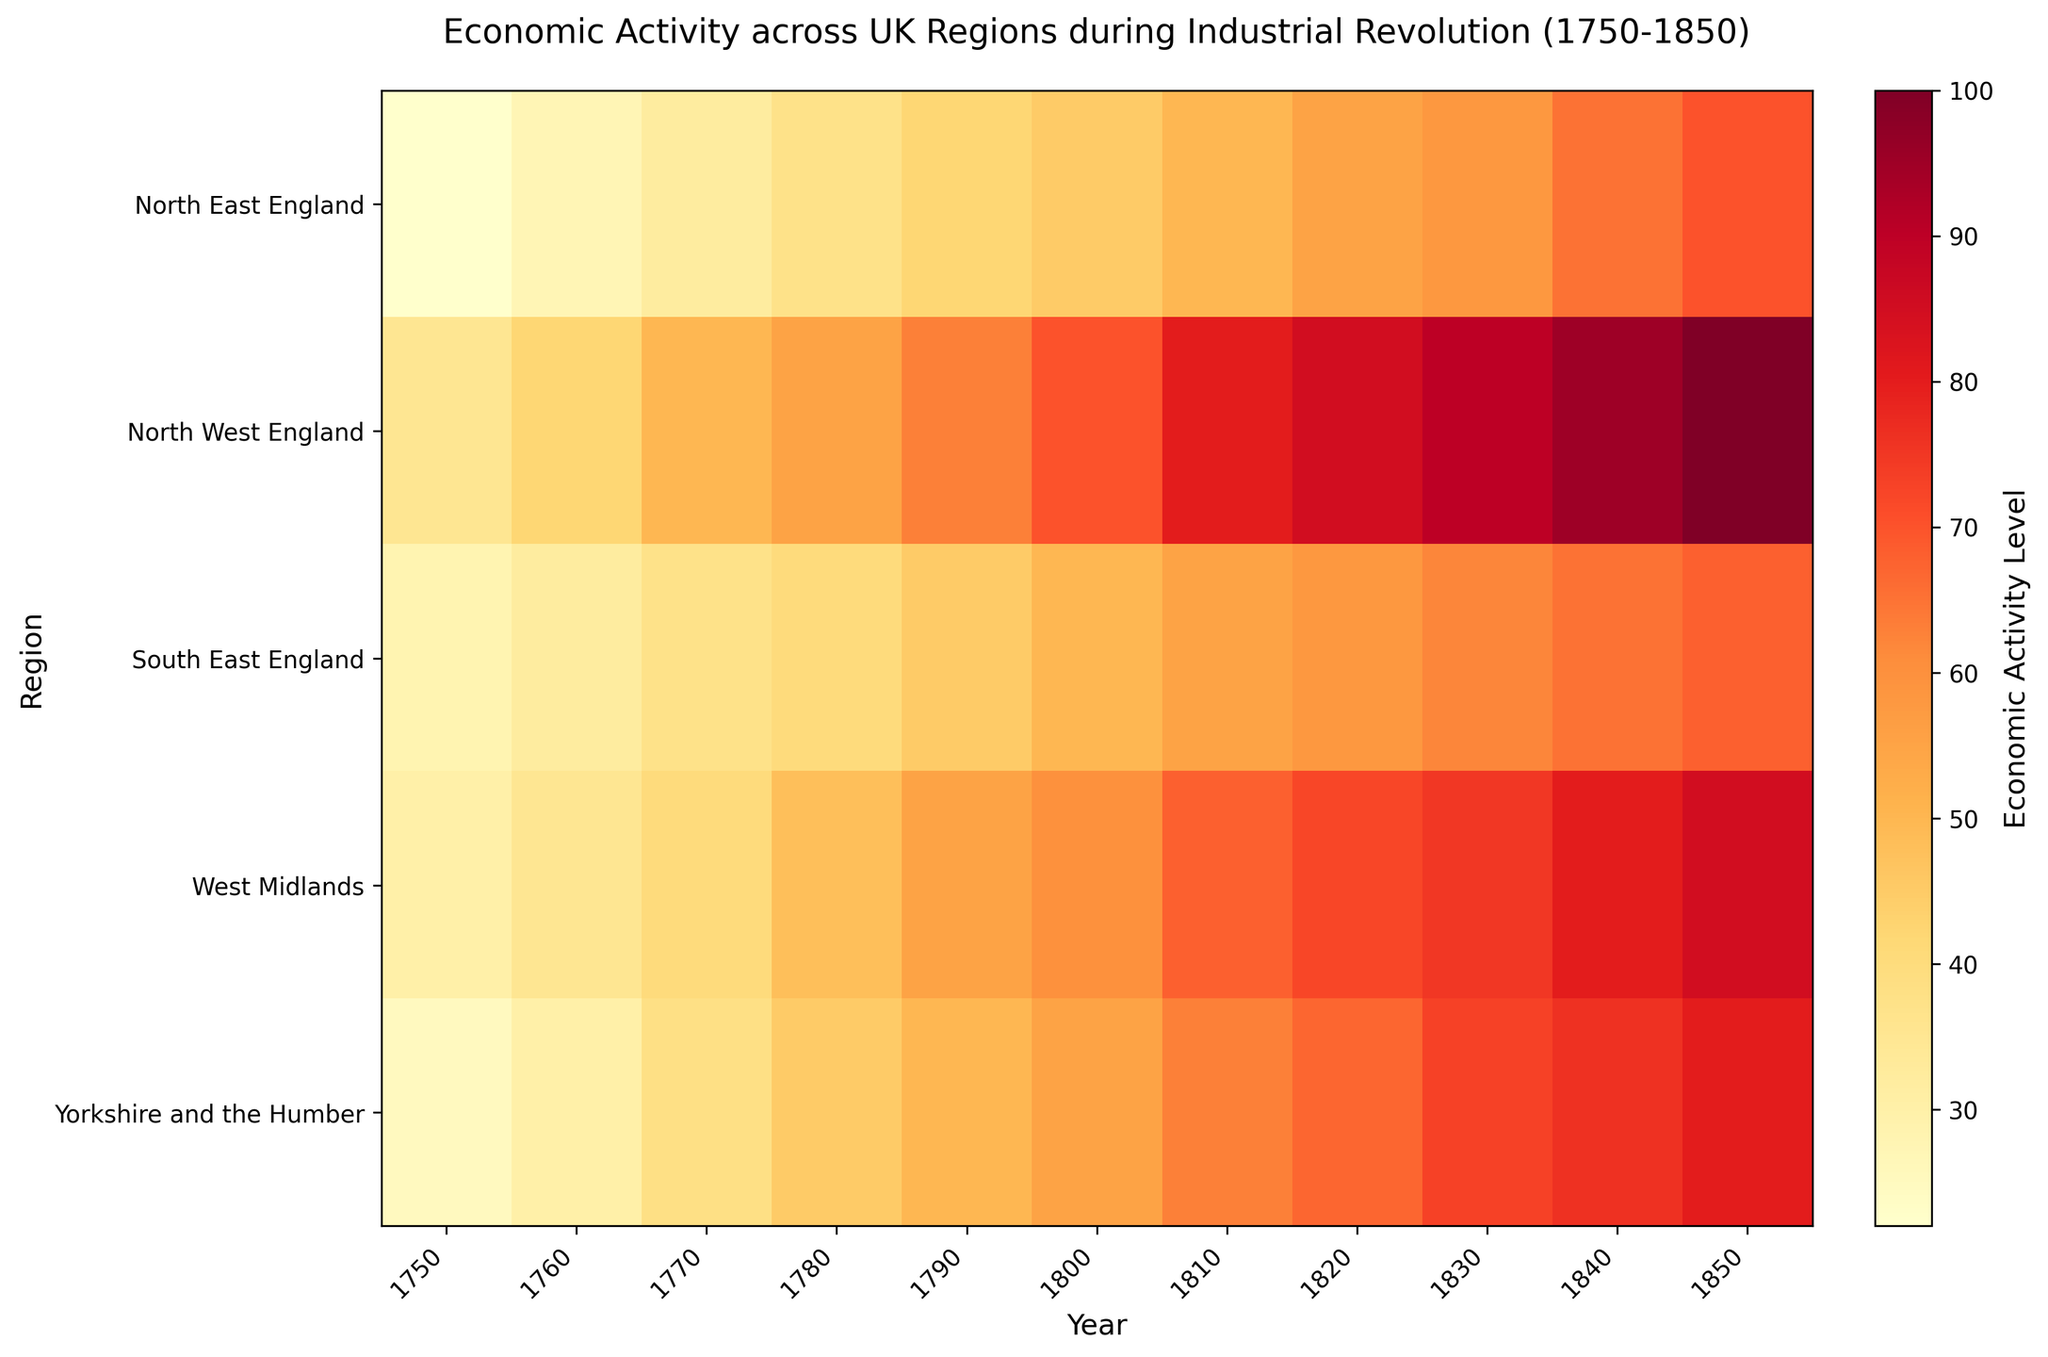What regions show the highest economic activity in the year 1850? To find the regions with the highest economic activity in 1850, look at the heatmap's rightmost column and identify the regions with the darkest (most intense) red color. The highest values indicate North West England.
Answer: North West England Which region had a higher increase in economic activity from 1750 to 1850, North West England or South East England? Calculate the increase for both regions by subtracting the 1750 value from the 1850 value. For North West England, the increase is 100 - 35 = 65. For South East England, it’s 68 - 28 = 40. Compare the two increases to find the greater one.
Answer: North West England How does the economic activity in Yorkshire and the Humber in 1830 compare to that in North East England in 1850? Look at the value for Yorkshire and the Humber in 1830 and compare it to North East England in 1850. Yorkshire and the Humber in 1830 is 73, and North East England in 1850 is 70. Since 73 is greater than 70, Yorkshire and the Humber in 1830 had higher economic activity.
Answer: Yorkshire and the Humber had higher economic activity What is the difference in economic activity between West Midlands and North East England in 1840? Find the values for West Midlands and North East England in 1840. West Midlands is 80, and North East England is 65. The difference is 80 - 65 = 15.
Answer: 15 Which region showed the most consistent increase in economic activity from 1750 to 1850? A consistent increase would show a gradual, steady color change without abrupt shifts. Look for a region with color that transitions smoothly from light to dark. North West England shows a consistent increase across the years.
Answer: North West England In the year 1820, which regions had economic activity levels higher than 70? Check the heatmap for the year 1820 and identify regions where the color intensity or value is higher than 70. Regions include North West England (85) and West Midlands (72).
Answer: North West England, West Midlands What trend do you observe in the economic activity of North East England from 1750 to 1850? Observe the color change for North East England across the years. The color becomes progressively darker from 1750 (22) to 1850 (70), indicating an increasing trend in economic activity.
Answer: Increasing trend In which decade did South East England's economic activity cross the midway (median) value of all its recorded years from 1750 to 1850? Calculate the median value for South East England, which is (28, 32, 37, 40, 45, 50, 55, 58, 62, 65, 68) => Median value = 50. Identify the first decade when the economic activity exceeds 50, occurring in 1810 (55).
Answer: 1810 